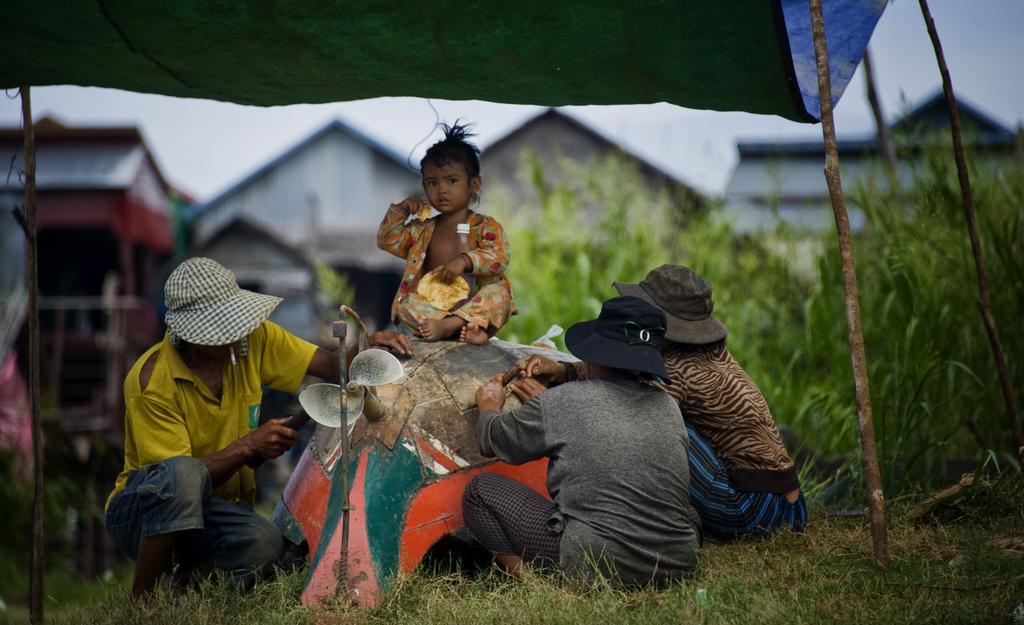How would you summarize this image in a sentence or two? In this picture we can see three people on the grass, child on an object, tent, plants, sheds, some objects and in the background we can see the sky. 